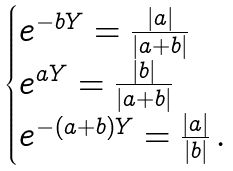Convert formula to latex. <formula><loc_0><loc_0><loc_500><loc_500>\begin{cases} e ^ { - b Y } = \frac { | a | } { | a + b | } \\ e ^ { a Y } = \frac { | b | } { | a + b | } \\ e ^ { - ( a + b ) Y } = \frac { | a | } { | b | } \, . \end{cases}</formula> 